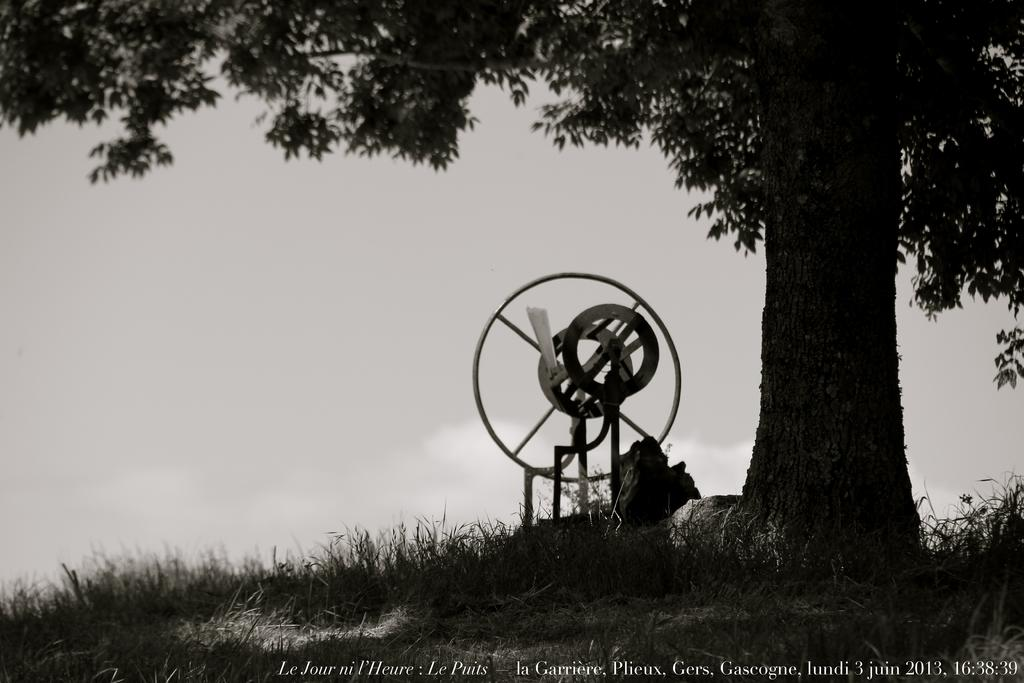What type of vegetation is present in the picture? There is a tree and grass in the picture. What can be found near the tree? There is an object near the tree. What is the condition of the sky in the picture? The sky is clear in the picture. How many crayons are being used to draw the tree in the picture? There are no crayons present in the picture, as it is an actual photograph of a tree and not a drawing. Can you tell me the birth date of the tree in the picture? It is not possible to determine the exact birth date of the tree in the picture, as trees do not have birthdays like humans. 